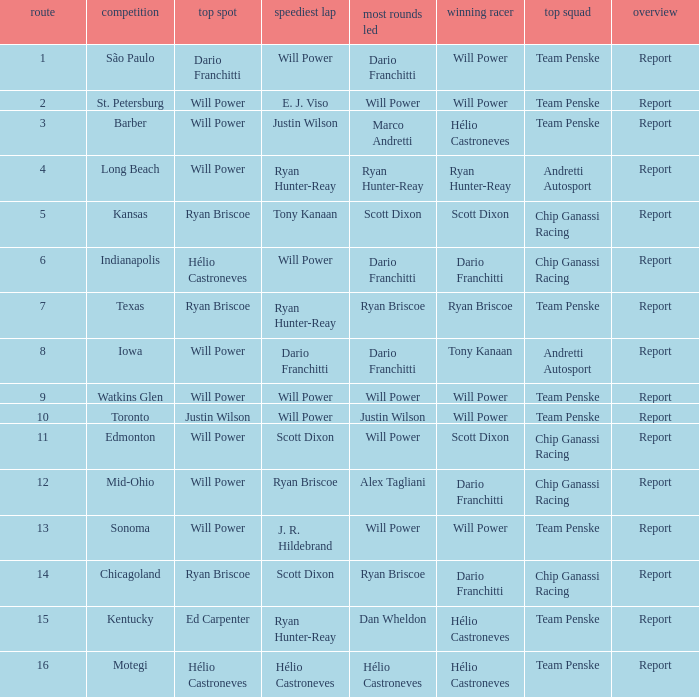What is the report for races where Will Power had both pole position and fastest lap? Report. 